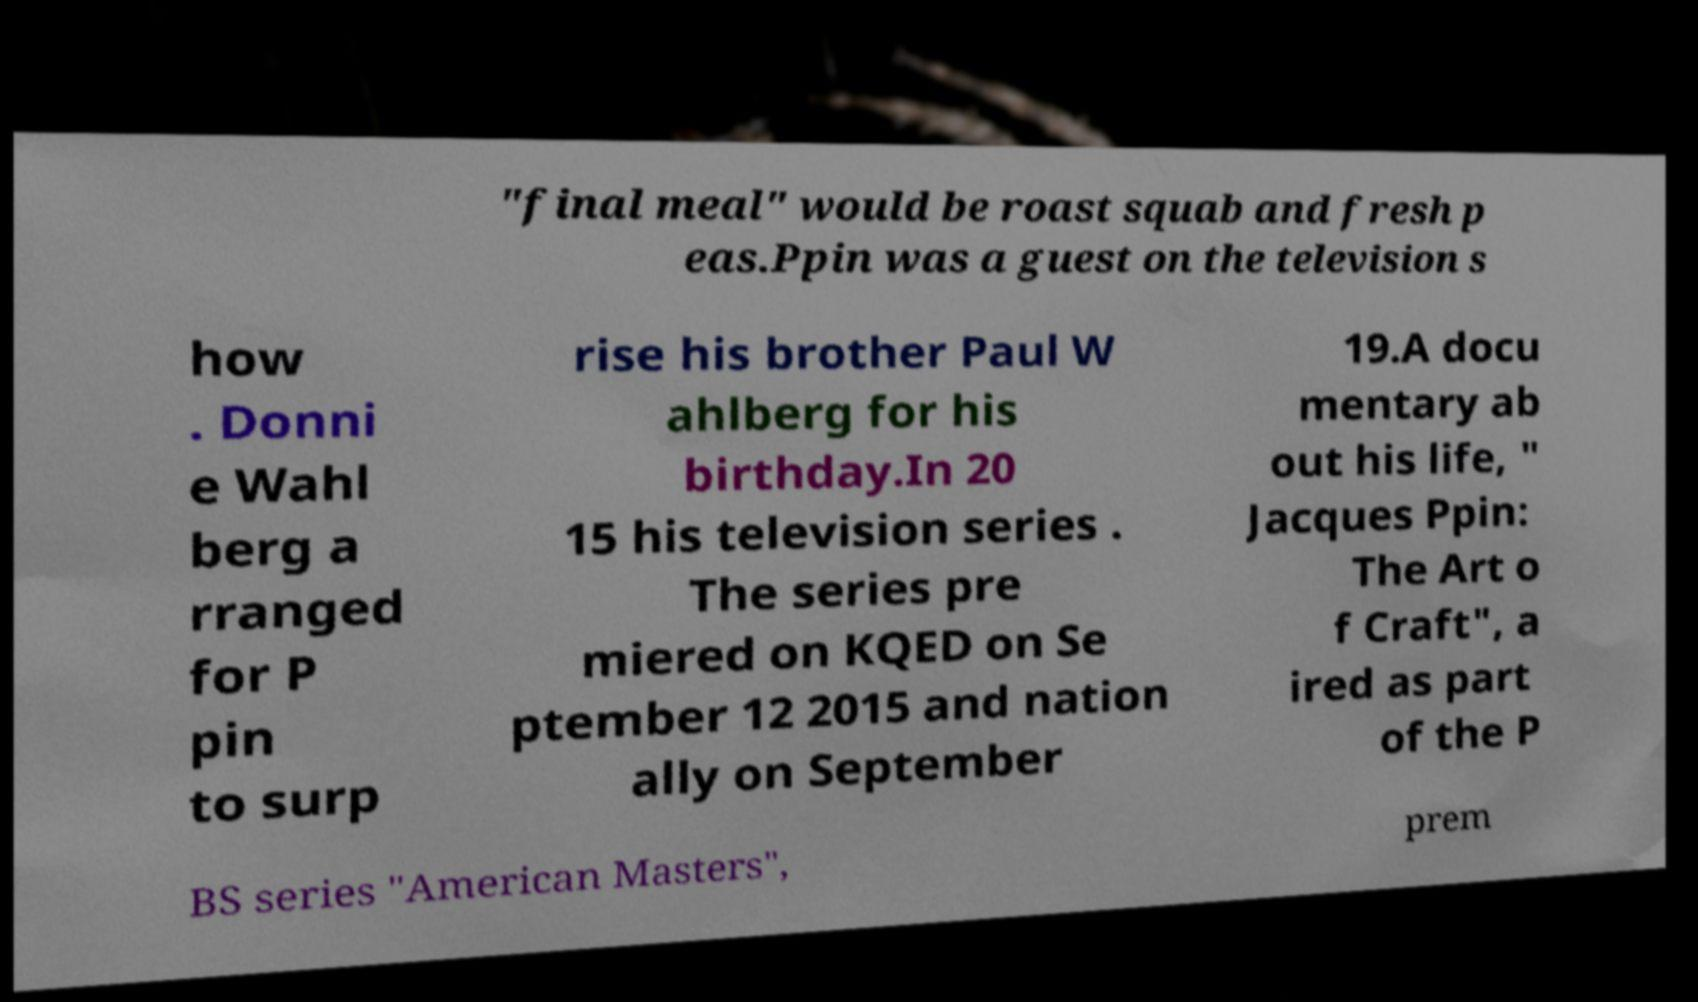Could you extract and type out the text from this image? "final meal" would be roast squab and fresh p eas.Ppin was a guest on the television s how . Donni e Wahl berg a rranged for P pin to surp rise his brother Paul W ahlberg for his birthday.In 20 15 his television series . The series pre miered on KQED on Se ptember 12 2015 and nation ally on September 19.A docu mentary ab out his life, " Jacques Ppin: The Art o f Craft", a ired as part of the P BS series "American Masters", prem 